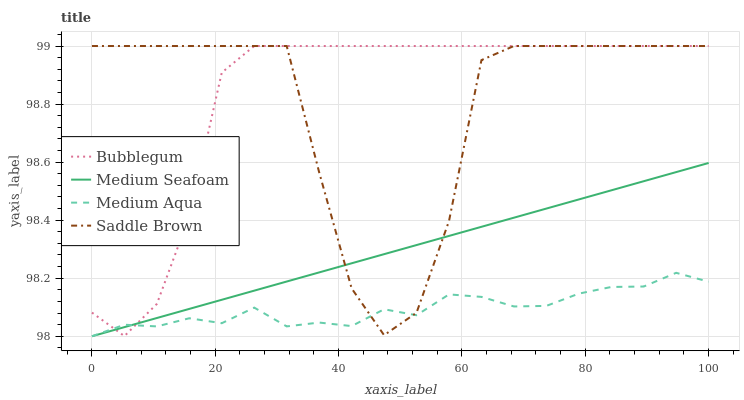Does Medium Aqua have the minimum area under the curve?
Answer yes or no. Yes. Does Bubblegum have the maximum area under the curve?
Answer yes or no. Yes. Does Medium Seafoam have the minimum area under the curve?
Answer yes or no. No. Does Medium Seafoam have the maximum area under the curve?
Answer yes or no. No. Is Medium Seafoam the smoothest?
Answer yes or no. Yes. Is Saddle Brown the roughest?
Answer yes or no. Yes. Is Bubblegum the smoothest?
Answer yes or no. No. Is Bubblegum the roughest?
Answer yes or no. No. Does Medium Aqua have the lowest value?
Answer yes or no. Yes. Does Bubblegum have the lowest value?
Answer yes or no. No. Does Saddle Brown have the highest value?
Answer yes or no. Yes. Does Medium Seafoam have the highest value?
Answer yes or no. No. Does Bubblegum intersect Medium Seafoam?
Answer yes or no. Yes. Is Bubblegum less than Medium Seafoam?
Answer yes or no. No. Is Bubblegum greater than Medium Seafoam?
Answer yes or no. No. 